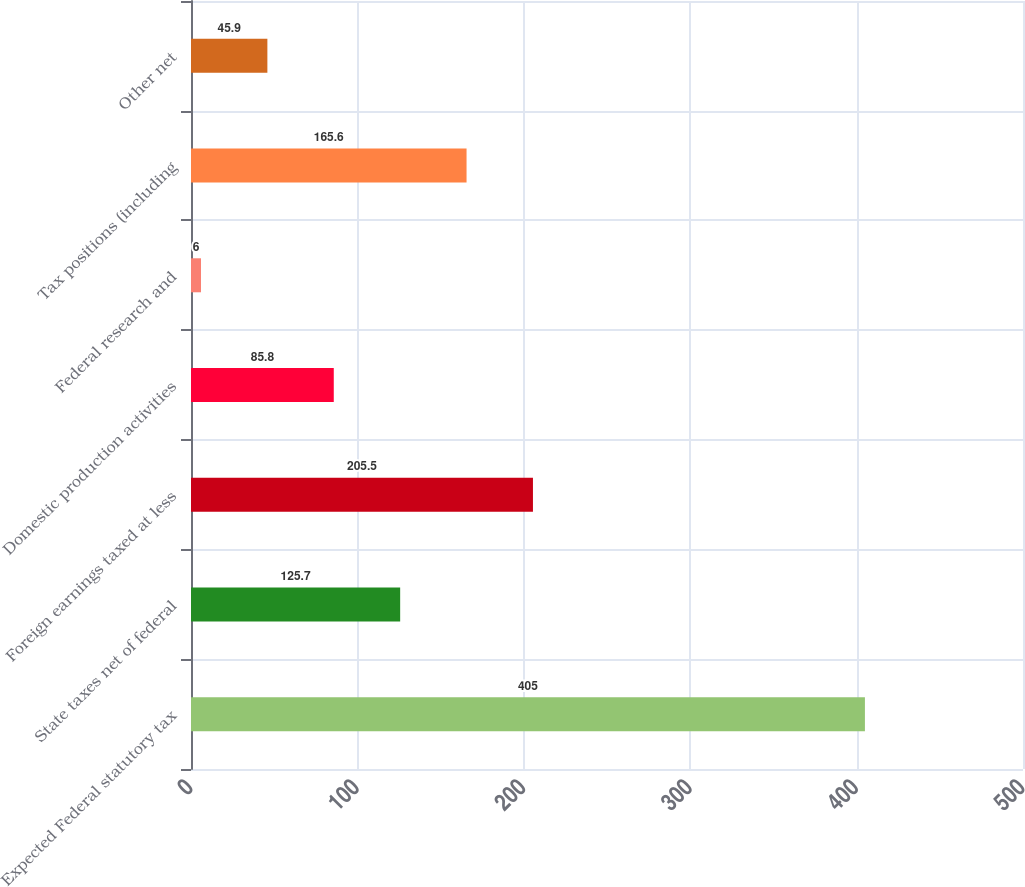Convert chart to OTSL. <chart><loc_0><loc_0><loc_500><loc_500><bar_chart><fcel>Expected Federal statutory tax<fcel>State taxes net of federal<fcel>Foreign earnings taxed at less<fcel>Domestic production activities<fcel>Federal research and<fcel>Tax positions (including<fcel>Other net<nl><fcel>405<fcel>125.7<fcel>205.5<fcel>85.8<fcel>6<fcel>165.6<fcel>45.9<nl></chart> 